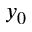<formula> <loc_0><loc_0><loc_500><loc_500>y _ { 0 }</formula> 